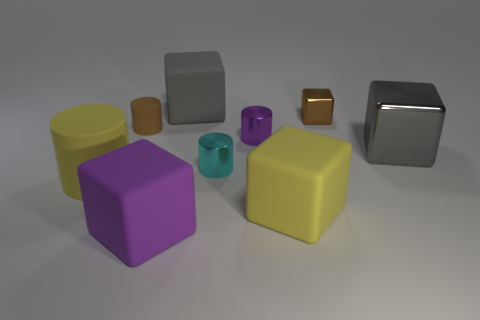Subtract 1 blocks. How many blocks are left? 4 Subtract all brown blocks. How many blocks are left? 4 Subtract all yellow blocks. How many blocks are left? 4 Subtract all green cubes. Subtract all green spheres. How many cubes are left? 5 Add 1 large green matte things. How many objects exist? 10 Subtract all cylinders. How many objects are left? 5 Subtract all cubes. Subtract all purple metal cylinders. How many objects are left? 3 Add 7 metal cylinders. How many metal cylinders are left? 9 Add 4 yellow rubber objects. How many yellow rubber objects exist? 6 Subtract 1 cyan cylinders. How many objects are left? 8 